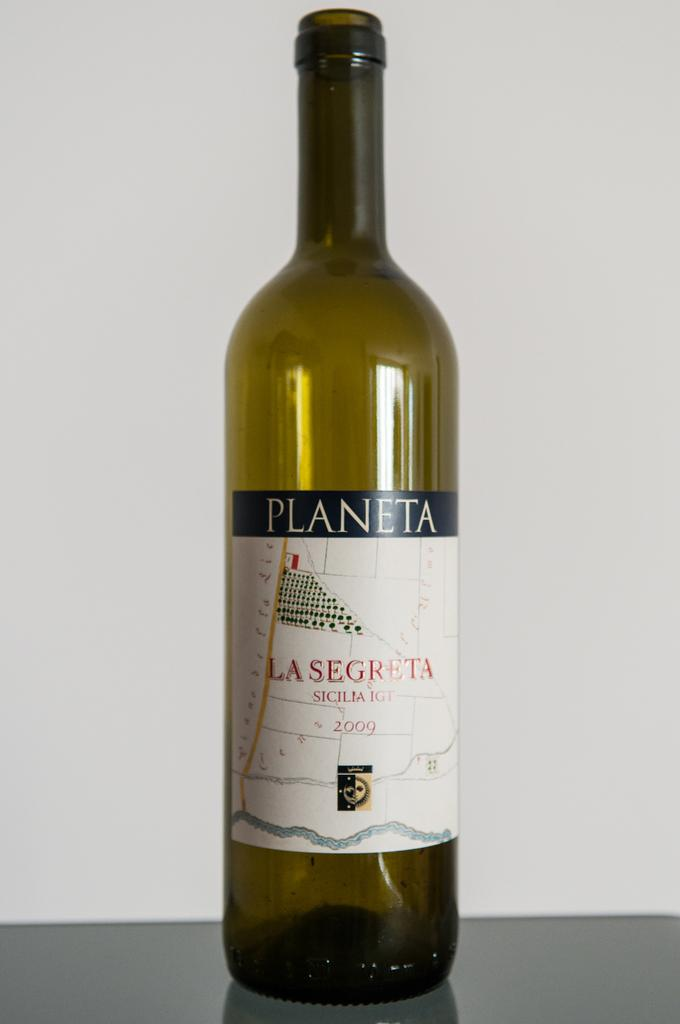<image>
Give a short and clear explanation of the subsequent image. An empty bottle that once contained a 2009 vintage of Planeta wine. 